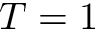Convert formula to latex. <formula><loc_0><loc_0><loc_500><loc_500>T = 1</formula> 